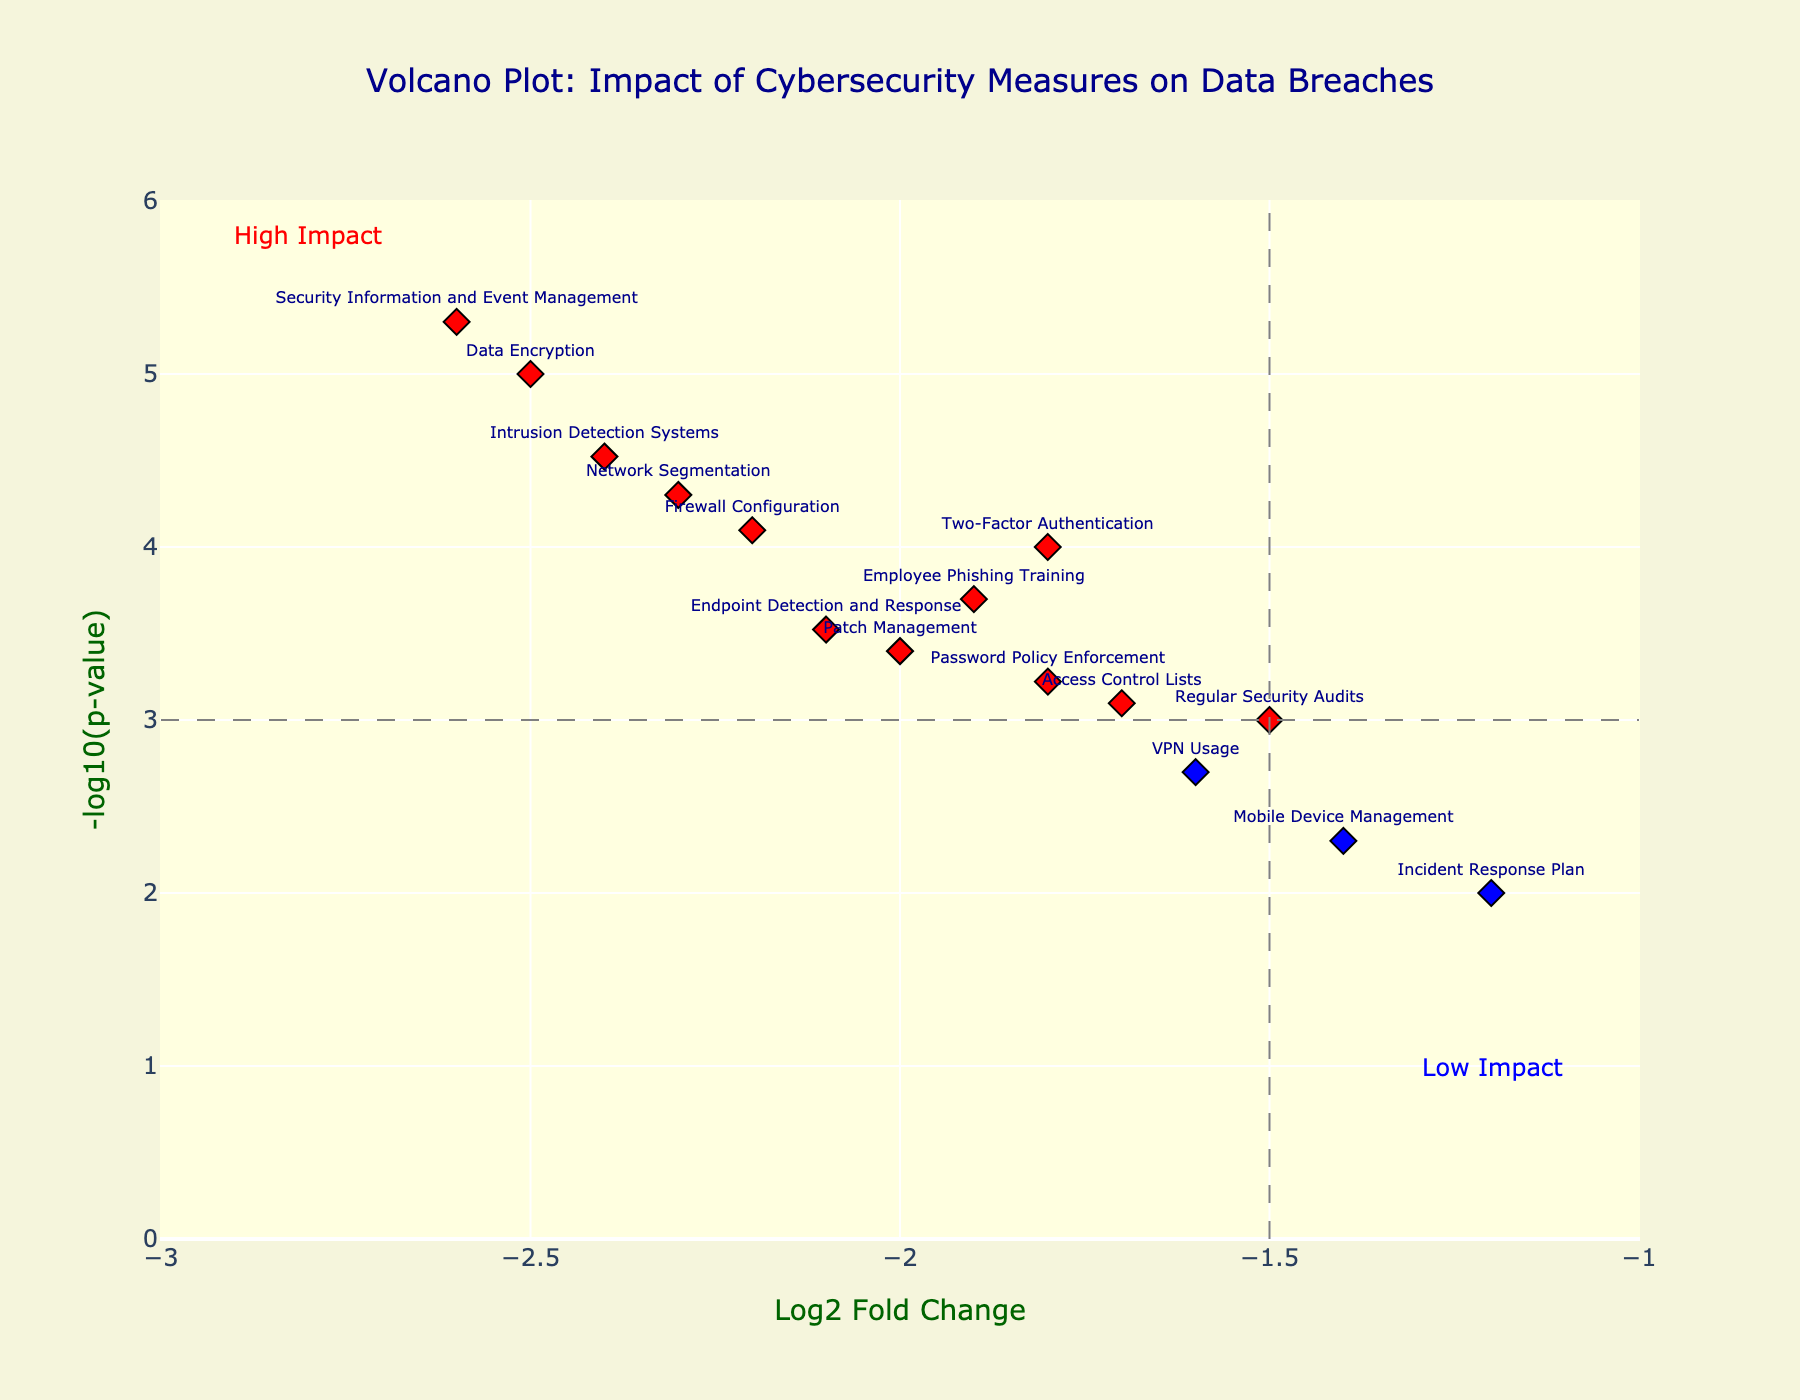How many cybersecurity measures are displayed in the plot? Count the number of unique data points plotted on the figure based on the different labels or measures. Each measure has its unique position marked by a diamond symbol.
Answer: 15 Which measure demonstrates the highest impact in reducing data breaches? The measure with the most negative log2 fold change and a high -log10(p-value) indicates the highest impact. Look for the measure positioned farthest to the left in the red region, which has both high statistical significance and largest fold change.
Answer: Security Information and Event Management What is the log2 fold change and p-value for Data Encryption? Locate the label "Data Encryption" on the figure and read its corresponding position on both the x-axis (log2 fold change) and y-axis (p-value). The log2 fold change is -2.5 and p-value is 0.00001.
Answer: Log2 Fold Change: -2.5, P-value: 0.00001 Between Two-Factor Authentication and Mobile Device Management, which has a lower p-value? Compare the y-axis positions of the two measures. The measure farther up the y-axis has a lower p-value due to the -log10(p-value) transformation. Mobile Device Management is lower on the y-axis than Two-Factor Authentication.
Answer: Two-Factor Authentication Which cybersecurity measure has the least impact according to this plot? Identify the measure closest to the origin on the x-axis (log2 fold change) and lowest on the y-axis (-log10(p-value)), while being in the blue region.
Answer: Incident Response Plan How many cybersecurity measures have a -log10(p-value) greater than 4? Count the number of data points that are above the value of 4 on the y-axis. These points have a high statistical significance.
Answer: 7 What color represents security measures with high impact? The measures in the red color region have the highest impact, characterized by large negative log2 fold change and high -log10(p-value).
Answer: Red What does the gray dashed vertical line at -1.5 on the x-axis signify? The vertical line at -1.5 on the x-axis acts as a threshold to differentiate between less impactful measures to the right and more impactful measures to the left.
Answer: Threshold for impact What is the significance of a higher position on the y-axis in this plot? A higher position on the y-axis indicates a smaller p-value, therefore greater statistical significance, due to the -log10 transformation.
Answer: Greater statistical significance Which measure has a greater impact, Network Segmentation or Patch Management? Compare their positions on the x-axis. The measure farther to the left (more negative log2 fold change) indicates a greater impact. Network Segmentation is farther to the left than Patch Management.
Answer: Network Segmentation 